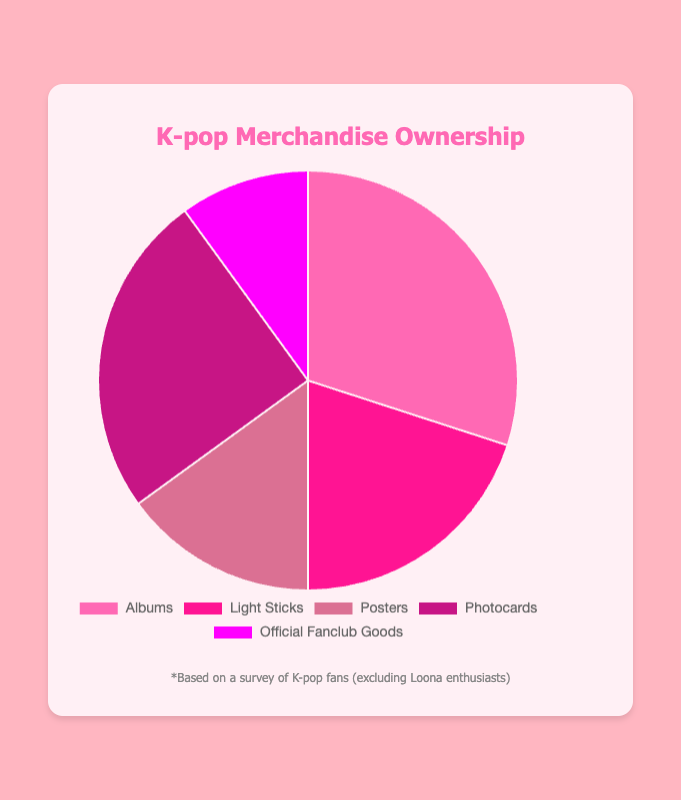What's the most owned type of K-pop merchandise among fans? The pie chart shows "Albums" as the largest slice of the pie, indicating it has the highest percentage among all categories.
Answer: Albums How much more popular are albums than light sticks? To find how much more popular albums are than light sticks, subtract the percentage of light sticks from the percentage of albums: 30% - 20% = 10%.
Answer: 10% What percentage of fans own either photocards or official fanclub goods? Add the percentages for photocards and official fanclub goods: 25% + 10% = 35%.
Answer: 35% Which is less common, posters or official fanclub goods, and by how much? Subtract the percentage of official fanclub goods from the percentage of posters: 15% - 10% = 5%. Posters are more common.
Answer: Official Fanclub Goods, 5% What's the combined percentage of fans owning albums or light sticks? Add the percentages of albums and light sticks: 30% + 20% = 50%.
Answer: 50% Is the percentage of fans owning photocards larger than those owning posters and official fanclub goods combined? First, add the percentages of posters and official fanclub goods: 15% + 10% = 25%. Then compare it with the percentage for photocards: 25% = 25%. They are equal.
Answer: No What merchandise category makes up exactly a quarter of the pie chart? The chart shows that photocards represent exactly 25% of the pie.
Answer: Photocards Rank the categories of merchandise from most to least owned. Based on the pie chart: Albums (30%), Photocards (25%), Light Sticks (20%), Posters (15%), Official Fanclub Goods (10%).
Answer: Albums, Photocards, Light Sticks, Posters, Official Fanclub Goods What is the difference in percentage points between the least common and most common merchandise? Subtract the percentage of the least common (Official Fanclub Goods, 10%) from the most common (Albums, 30%): 30% - 10% = 20%.
Answer: 20% What visual element is used to differentiate between categories in the pie chart? The categories in the pie chart are differentiated by different slice colors.
Answer: Color 